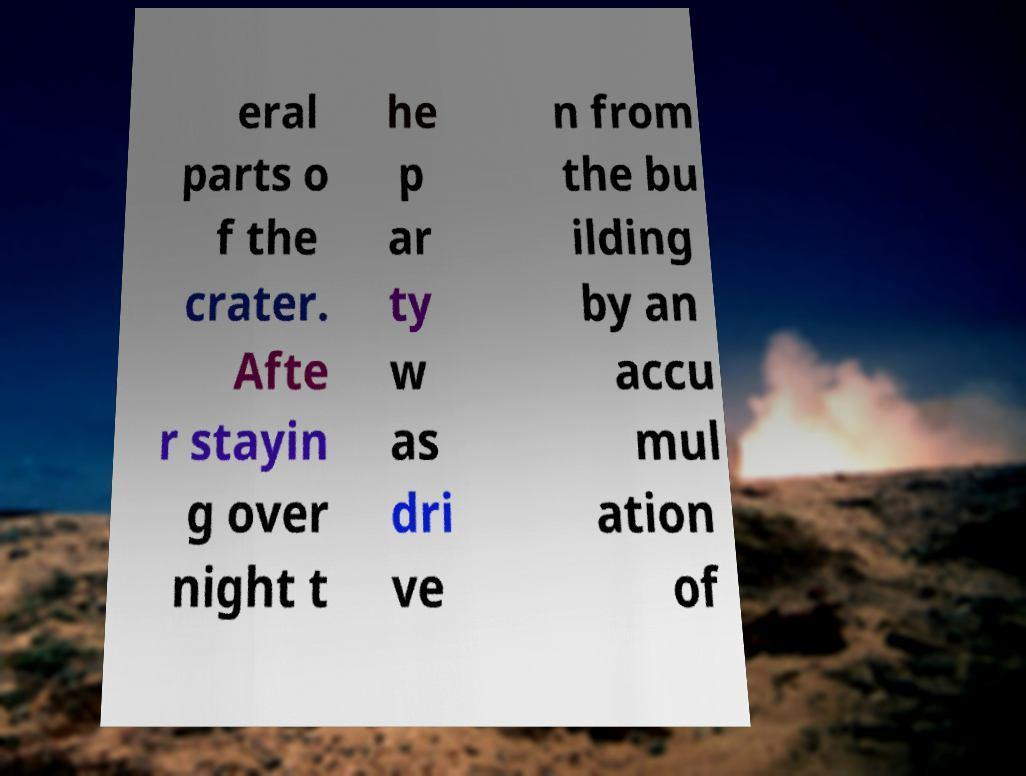For documentation purposes, I need the text within this image transcribed. Could you provide that? eral parts o f the crater. Afte r stayin g over night t he p ar ty w as dri ve n from the bu ilding by an accu mul ation of 